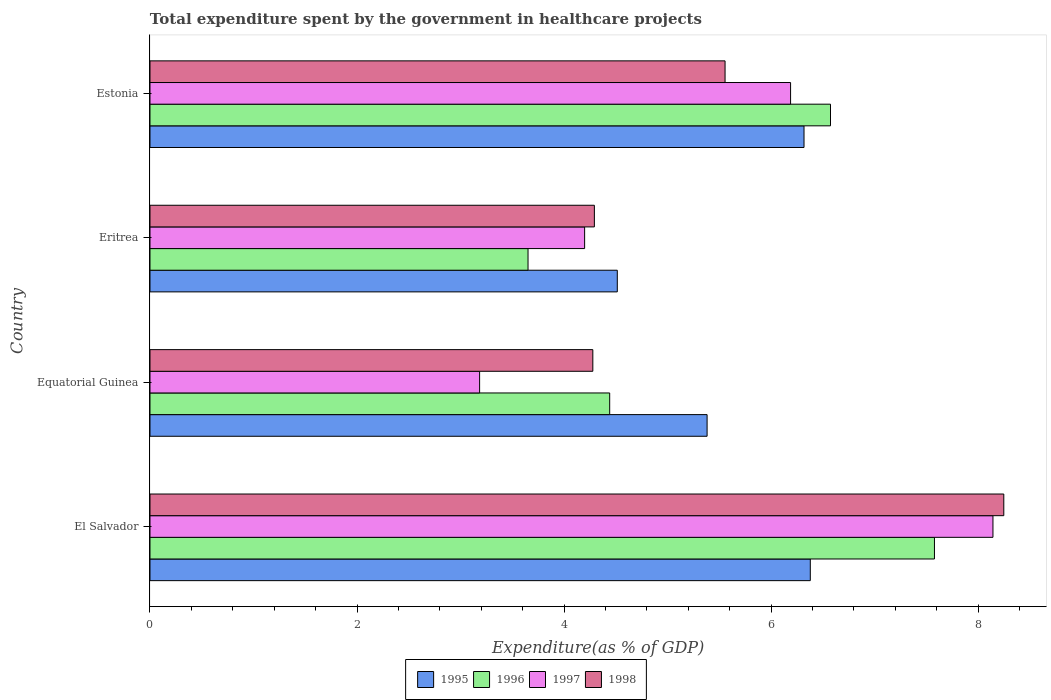How many groups of bars are there?
Keep it short and to the point. 4. Are the number of bars per tick equal to the number of legend labels?
Keep it short and to the point. Yes. What is the label of the 1st group of bars from the top?
Give a very brief answer. Estonia. What is the total expenditure spent by the government in healthcare projects in 1996 in Estonia?
Offer a terse response. 6.57. Across all countries, what is the maximum total expenditure spent by the government in healthcare projects in 1996?
Keep it short and to the point. 7.58. Across all countries, what is the minimum total expenditure spent by the government in healthcare projects in 1995?
Make the answer very short. 4.51. In which country was the total expenditure spent by the government in healthcare projects in 1996 maximum?
Keep it short and to the point. El Salvador. In which country was the total expenditure spent by the government in healthcare projects in 1998 minimum?
Give a very brief answer. Equatorial Guinea. What is the total total expenditure spent by the government in healthcare projects in 1997 in the graph?
Offer a terse response. 21.71. What is the difference between the total expenditure spent by the government in healthcare projects in 1996 in Eritrea and that in Estonia?
Provide a short and direct response. -2.92. What is the difference between the total expenditure spent by the government in healthcare projects in 1998 in Eritrea and the total expenditure spent by the government in healthcare projects in 1995 in Equatorial Guinea?
Your response must be concise. -1.09. What is the average total expenditure spent by the government in healthcare projects in 1998 per country?
Keep it short and to the point. 5.59. What is the difference between the total expenditure spent by the government in healthcare projects in 1996 and total expenditure spent by the government in healthcare projects in 1998 in Eritrea?
Your answer should be compact. -0.64. What is the ratio of the total expenditure spent by the government in healthcare projects in 1997 in Eritrea to that in Estonia?
Give a very brief answer. 0.68. Is the total expenditure spent by the government in healthcare projects in 1996 in Equatorial Guinea less than that in Eritrea?
Your answer should be compact. No. What is the difference between the highest and the second highest total expenditure spent by the government in healthcare projects in 1998?
Keep it short and to the point. 2.69. What is the difference between the highest and the lowest total expenditure spent by the government in healthcare projects in 1998?
Offer a very short reply. 3.97. What does the 2nd bar from the bottom in Eritrea represents?
Your response must be concise. 1996. How many bars are there?
Provide a succinct answer. 16. How many countries are there in the graph?
Offer a very short reply. 4. Does the graph contain any zero values?
Give a very brief answer. No. Where does the legend appear in the graph?
Offer a terse response. Bottom center. How are the legend labels stacked?
Your answer should be compact. Horizontal. What is the title of the graph?
Offer a very short reply. Total expenditure spent by the government in healthcare projects. Does "1981" appear as one of the legend labels in the graph?
Provide a succinct answer. No. What is the label or title of the X-axis?
Provide a short and direct response. Expenditure(as % of GDP). What is the Expenditure(as % of GDP) in 1995 in El Salvador?
Make the answer very short. 6.38. What is the Expenditure(as % of GDP) in 1996 in El Salvador?
Offer a terse response. 7.58. What is the Expenditure(as % of GDP) in 1997 in El Salvador?
Ensure brevity in your answer.  8.14. What is the Expenditure(as % of GDP) of 1998 in El Salvador?
Give a very brief answer. 8.25. What is the Expenditure(as % of GDP) of 1995 in Equatorial Guinea?
Offer a very short reply. 5.38. What is the Expenditure(as % of GDP) in 1996 in Equatorial Guinea?
Keep it short and to the point. 4.44. What is the Expenditure(as % of GDP) in 1997 in Equatorial Guinea?
Make the answer very short. 3.18. What is the Expenditure(as % of GDP) in 1998 in Equatorial Guinea?
Your response must be concise. 4.28. What is the Expenditure(as % of GDP) in 1995 in Eritrea?
Make the answer very short. 4.51. What is the Expenditure(as % of GDP) in 1996 in Eritrea?
Make the answer very short. 3.65. What is the Expenditure(as % of GDP) in 1997 in Eritrea?
Keep it short and to the point. 4.2. What is the Expenditure(as % of GDP) of 1998 in Eritrea?
Your response must be concise. 4.29. What is the Expenditure(as % of GDP) of 1995 in Estonia?
Offer a very short reply. 6.32. What is the Expenditure(as % of GDP) in 1996 in Estonia?
Offer a terse response. 6.57. What is the Expenditure(as % of GDP) of 1997 in Estonia?
Provide a short and direct response. 6.19. What is the Expenditure(as % of GDP) in 1998 in Estonia?
Keep it short and to the point. 5.56. Across all countries, what is the maximum Expenditure(as % of GDP) in 1995?
Give a very brief answer. 6.38. Across all countries, what is the maximum Expenditure(as % of GDP) of 1996?
Keep it short and to the point. 7.58. Across all countries, what is the maximum Expenditure(as % of GDP) in 1997?
Provide a succinct answer. 8.14. Across all countries, what is the maximum Expenditure(as % of GDP) of 1998?
Your answer should be very brief. 8.25. Across all countries, what is the minimum Expenditure(as % of GDP) of 1995?
Your answer should be compact. 4.51. Across all countries, what is the minimum Expenditure(as % of GDP) of 1996?
Ensure brevity in your answer.  3.65. Across all countries, what is the minimum Expenditure(as % of GDP) of 1997?
Your answer should be compact. 3.18. Across all countries, what is the minimum Expenditure(as % of GDP) of 1998?
Give a very brief answer. 4.28. What is the total Expenditure(as % of GDP) in 1995 in the graph?
Make the answer very short. 22.59. What is the total Expenditure(as % of GDP) in 1996 in the graph?
Keep it short and to the point. 22.24. What is the total Expenditure(as % of GDP) of 1997 in the graph?
Keep it short and to the point. 21.71. What is the total Expenditure(as % of GDP) of 1998 in the graph?
Offer a terse response. 22.37. What is the difference between the Expenditure(as % of GDP) of 1996 in El Salvador and that in Equatorial Guinea?
Offer a very short reply. 3.14. What is the difference between the Expenditure(as % of GDP) in 1997 in El Salvador and that in Equatorial Guinea?
Your answer should be compact. 4.96. What is the difference between the Expenditure(as % of GDP) in 1998 in El Salvador and that in Equatorial Guinea?
Your answer should be very brief. 3.97. What is the difference between the Expenditure(as % of GDP) of 1995 in El Salvador and that in Eritrea?
Offer a terse response. 1.86. What is the difference between the Expenditure(as % of GDP) of 1996 in El Salvador and that in Eritrea?
Your answer should be very brief. 3.93. What is the difference between the Expenditure(as % of GDP) of 1997 in El Salvador and that in Eritrea?
Your answer should be compact. 3.94. What is the difference between the Expenditure(as % of GDP) of 1998 in El Salvador and that in Eritrea?
Make the answer very short. 3.96. What is the difference between the Expenditure(as % of GDP) of 1995 in El Salvador and that in Estonia?
Ensure brevity in your answer.  0.06. What is the difference between the Expenditure(as % of GDP) of 1996 in El Salvador and that in Estonia?
Your answer should be very brief. 1. What is the difference between the Expenditure(as % of GDP) of 1997 in El Salvador and that in Estonia?
Keep it short and to the point. 1.95. What is the difference between the Expenditure(as % of GDP) in 1998 in El Salvador and that in Estonia?
Your answer should be compact. 2.69. What is the difference between the Expenditure(as % of GDP) of 1995 in Equatorial Guinea and that in Eritrea?
Your answer should be compact. 0.87. What is the difference between the Expenditure(as % of GDP) of 1996 in Equatorial Guinea and that in Eritrea?
Your answer should be very brief. 0.79. What is the difference between the Expenditure(as % of GDP) in 1997 in Equatorial Guinea and that in Eritrea?
Provide a short and direct response. -1.01. What is the difference between the Expenditure(as % of GDP) of 1998 in Equatorial Guinea and that in Eritrea?
Keep it short and to the point. -0.01. What is the difference between the Expenditure(as % of GDP) of 1995 in Equatorial Guinea and that in Estonia?
Offer a terse response. -0.94. What is the difference between the Expenditure(as % of GDP) of 1996 in Equatorial Guinea and that in Estonia?
Provide a short and direct response. -2.13. What is the difference between the Expenditure(as % of GDP) in 1997 in Equatorial Guinea and that in Estonia?
Give a very brief answer. -3. What is the difference between the Expenditure(as % of GDP) in 1998 in Equatorial Guinea and that in Estonia?
Your answer should be compact. -1.28. What is the difference between the Expenditure(as % of GDP) in 1995 in Eritrea and that in Estonia?
Make the answer very short. -1.8. What is the difference between the Expenditure(as % of GDP) of 1996 in Eritrea and that in Estonia?
Give a very brief answer. -2.92. What is the difference between the Expenditure(as % of GDP) in 1997 in Eritrea and that in Estonia?
Offer a very short reply. -1.99. What is the difference between the Expenditure(as % of GDP) of 1998 in Eritrea and that in Estonia?
Keep it short and to the point. -1.26. What is the difference between the Expenditure(as % of GDP) of 1995 in El Salvador and the Expenditure(as % of GDP) of 1996 in Equatorial Guinea?
Provide a short and direct response. 1.94. What is the difference between the Expenditure(as % of GDP) in 1995 in El Salvador and the Expenditure(as % of GDP) in 1997 in Equatorial Guinea?
Offer a terse response. 3.19. What is the difference between the Expenditure(as % of GDP) of 1995 in El Salvador and the Expenditure(as % of GDP) of 1998 in Equatorial Guinea?
Provide a short and direct response. 2.1. What is the difference between the Expenditure(as % of GDP) of 1996 in El Salvador and the Expenditure(as % of GDP) of 1997 in Equatorial Guinea?
Provide a succinct answer. 4.39. What is the difference between the Expenditure(as % of GDP) in 1996 in El Salvador and the Expenditure(as % of GDP) in 1998 in Equatorial Guinea?
Make the answer very short. 3.3. What is the difference between the Expenditure(as % of GDP) of 1997 in El Salvador and the Expenditure(as % of GDP) of 1998 in Equatorial Guinea?
Give a very brief answer. 3.87. What is the difference between the Expenditure(as % of GDP) in 1995 in El Salvador and the Expenditure(as % of GDP) in 1996 in Eritrea?
Provide a short and direct response. 2.73. What is the difference between the Expenditure(as % of GDP) in 1995 in El Salvador and the Expenditure(as % of GDP) in 1997 in Eritrea?
Ensure brevity in your answer.  2.18. What is the difference between the Expenditure(as % of GDP) in 1995 in El Salvador and the Expenditure(as % of GDP) in 1998 in Eritrea?
Offer a very short reply. 2.09. What is the difference between the Expenditure(as % of GDP) in 1996 in El Salvador and the Expenditure(as % of GDP) in 1997 in Eritrea?
Give a very brief answer. 3.38. What is the difference between the Expenditure(as % of GDP) of 1996 in El Salvador and the Expenditure(as % of GDP) of 1998 in Eritrea?
Keep it short and to the point. 3.29. What is the difference between the Expenditure(as % of GDP) of 1997 in El Salvador and the Expenditure(as % of GDP) of 1998 in Eritrea?
Ensure brevity in your answer.  3.85. What is the difference between the Expenditure(as % of GDP) in 1995 in El Salvador and the Expenditure(as % of GDP) in 1996 in Estonia?
Provide a short and direct response. -0.2. What is the difference between the Expenditure(as % of GDP) in 1995 in El Salvador and the Expenditure(as % of GDP) in 1997 in Estonia?
Your answer should be compact. 0.19. What is the difference between the Expenditure(as % of GDP) in 1995 in El Salvador and the Expenditure(as % of GDP) in 1998 in Estonia?
Provide a short and direct response. 0.82. What is the difference between the Expenditure(as % of GDP) of 1996 in El Salvador and the Expenditure(as % of GDP) of 1997 in Estonia?
Ensure brevity in your answer.  1.39. What is the difference between the Expenditure(as % of GDP) in 1996 in El Salvador and the Expenditure(as % of GDP) in 1998 in Estonia?
Your response must be concise. 2.02. What is the difference between the Expenditure(as % of GDP) of 1997 in El Salvador and the Expenditure(as % of GDP) of 1998 in Estonia?
Provide a short and direct response. 2.59. What is the difference between the Expenditure(as % of GDP) in 1995 in Equatorial Guinea and the Expenditure(as % of GDP) in 1996 in Eritrea?
Ensure brevity in your answer.  1.73. What is the difference between the Expenditure(as % of GDP) in 1995 in Equatorial Guinea and the Expenditure(as % of GDP) in 1997 in Eritrea?
Your response must be concise. 1.18. What is the difference between the Expenditure(as % of GDP) in 1995 in Equatorial Guinea and the Expenditure(as % of GDP) in 1998 in Eritrea?
Keep it short and to the point. 1.09. What is the difference between the Expenditure(as % of GDP) in 1996 in Equatorial Guinea and the Expenditure(as % of GDP) in 1997 in Eritrea?
Your answer should be compact. 0.24. What is the difference between the Expenditure(as % of GDP) of 1996 in Equatorial Guinea and the Expenditure(as % of GDP) of 1998 in Eritrea?
Give a very brief answer. 0.15. What is the difference between the Expenditure(as % of GDP) of 1997 in Equatorial Guinea and the Expenditure(as % of GDP) of 1998 in Eritrea?
Offer a terse response. -1.11. What is the difference between the Expenditure(as % of GDP) in 1995 in Equatorial Guinea and the Expenditure(as % of GDP) in 1996 in Estonia?
Your answer should be very brief. -1.19. What is the difference between the Expenditure(as % of GDP) in 1995 in Equatorial Guinea and the Expenditure(as % of GDP) in 1997 in Estonia?
Provide a short and direct response. -0.81. What is the difference between the Expenditure(as % of GDP) in 1995 in Equatorial Guinea and the Expenditure(as % of GDP) in 1998 in Estonia?
Make the answer very short. -0.17. What is the difference between the Expenditure(as % of GDP) of 1996 in Equatorial Guinea and the Expenditure(as % of GDP) of 1997 in Estonia?
Offer a very short reply. -1.75. What is the difference between the Expenditure(as % of GDP) of 1996 in Equatorial Guinea and the Expenditure(as % of GDP) of 1998 in Estonia?
Give a very brief answer. -1.11. What is the difference between the Expenditure(as % of GDP) in 1997 in Equatorial Guinea and the Expenditure(as % of GDP) in 1998 in Estonia?
Offer a terse response. -2.37. What is the difference between the Expenditure(as % of GDP) in 1995 in Eritrea and the Expenditure(as % of GDP) in 1996 in Estonia?
Your answer should be very brief. -2.06. What is the difference between the Expenditure(as % of GDP) in 1995 in Eritrea and the Expenditure(as % of GDP) in 1997 in Estonia?
Keep it short and to the point. -1.67. What is the difference between the Expenditure(as % of GDP) of 1995 in Eritrea and the Expenditure(as % of GDP) of 1998 in Estonia?
Ensure brevity in your answer.  -1.04. What is the difference between the Expenditure(as % of GDP) of 1996 in Eritrea and the Expenditure(as % of GDP) of 1997 in Estonia?
Give a very brief answer. -2.54. What is the difference between the Expenditure(as % of GDP) in 1996 in Eritrea and the Expenditure(as % of GDP) in 1998 in Estonia?
Make the answer very short. -1.9. What is the difference between the Expenditure(as % of GDP) of 1997 in Eritrea and the Expenditure(as % of GDP) of 1998 in Estonia?
Keep it short and to the point. -1.36. What is the average Expenditure(as % of GDP) of 1995 per country?
Provide a succinct answer. 5.65. What is the average Expenditure(as % of GDP) in 1996 per country?
Your response must be concise. 5.56. What is the average Expenditure(as % of GDP) of 1997 per country?
Offer a terse response. 5.43. What is the average Expenditure(as % of GDP) of 1998 per country?
Your answer should be compact. 5.59. What is the difference between the Expenditure(as % of GDP) in 1995 and Expenditure(as % of GDP) in 1996 in El Salvador?
Make the answer very short. -1.2. What is the difference between the Expenditure(as % of GDP) in 1995 and Expenditure(as % of GDP) in 1997 in El Salvador?
Make the answer very short. -1.76. What is the difference between the Expenditure(as % of GDP) of 1995 and Expenditure(as % of GDP) of 1998 in El Salvador?
Ensure brevity in your answer.  -1.87. What is the difference between the Expenditure(as % of GDP) of 1996 and Expenditure(as % of GDP) of 1997 in El Salvador?
Provide a short and direct response. -0.56. What is the difference between the Expenditure(as % of GDP) of 1996 and Expenditure(as % of GDP) of 1998 in El Salvador?
Give a very brief answer. -0.67. What is the difference between the Expenditure(as % of GDP) in 1997 and Expenditure(as % of GDP) in 1998 in El Salvador?
Keep it short and to the point. -0.1. What is the difference between the Expenditure(as % of GDP) in 1995 and Expenditure(as % of GDP) in 1996 in Equatorial Guinea?
Your response must be concise. 0.94. What is the difference between the Expenditure(as % of GDP) in 1995 and Expenditure(as % of GDP) in 1997 in Equatorial Guinea?
Provide a short and direct response. 2.2. What is the difference between the Expenditure(as % of GDP) of 1995 and Expenditure(as % of GDP) of 1998 in Equatorial Guinea?
Keep it short and to the point. 1.1. What is the difference between the Expenditure(as % of GDP) of 1996 and Expenditure(as % of GDP) of 1997 in Equatorial Guinea?
Provide a short and direct response. 1.26. What is the difference between the Expenditure(as % of GDP) of 1996 and Expenditure(as % of GDP) of 1998 in Equatorial Guinea?
Your answer should be compact. 0.16. What is the difference between the Expenditure(as % of GDP) of 1997 and Expenditure(as % of GDP) of 1998 in Equatorial Guinea?
Your answer should be very brief. -1.09. What is the difference between the Expenditure(as % of GDP) of 1995 and Expenditure(as % of GDP) of 1996 in Eritrea?
Make the answer very short. 0.86. What is the difference between the Expenditure(as % of GDP) of 1995 and Expenditure(as % of GDP) of 1997 in Eritrea?
Give a very brief answer. 0.32. What is the difference between the Expenditure(as % of GDP) of 1995 and Expenditure(as % of GDP) of 1998 in Eritrea?
Offer a terse response. 0.22. What is the difference between the Expenditure(as % of GDP) in 1996 and Expenditure(as % of GDP) in 1997 in Eritrea?
Your answer should be very brief. -0.55. What is the difference between the Expenditure(as % of GDP) in 1996 and Expenditure(as % of GDP) in 1998 in Eritrea?
Your answer should be very brief. -0.64. What is the difference between the Expenditure(as % of GDP) in 1997 and Expenditure(as % of GDP) in 1998 in Eritrea?
Your response must be concise. -0.09. What is the difference between the Expenditure(as % of GDP) of 1995 and Expenditure(as % of GDP) of 1996 in Estonia?
Your response must be concise. -0.26. What is the difference between the Expenditure(as % of GDP) of 1995 and Expenditure(as % of GDP) of 1997 in Estonia?
Offer a very short reply. 0.13. What is the difference between the Expenditure(as % of GDP) in 1995 and Expenditure(as % of GDP) in 1998 in Estonia?
Offer a terse response. 0.76. What is the difference between the Expenditure(as % of GDP) of 1996 and Expenditure(as % of GDP) of 1997 in Estonia?
Provide a succinct answer. 0.39. What is the difference between the Expenditure(as % of GDP) of 1996 and Expenditure(as % of GDP) of 1998 in Estonia?
Offer a terse response. 1.02. What is the difference between the Expenditure(as % of GDP) in 1997 and Expenditure(as % of GDP) in 1998 in Estonia?
Provide a short and direct response. 0.63. What is the ratio of the Expenditure(as % of GDP) of 1995 in El Salvador to that in Equatorial Guinea?
Keep it short and to the point. 1.19. What is the ratio of the Expenditure(as % of GDP) in 1996 in El Salvador to that in Equatorial Guinea?
Your answer should be compact. 1.71. What is the ratio of the Expenditure(as % of GDP) of 1997 in El Salvador to that in Equatorial Guinea?
Provide a short and direct response. 2.56. What is the ratio of the Expenditure(as % of GDP) of 1998 in El Salvador to that in Equatorial Guinea?
Ensure brevity in your answer.  1.93. What is the ratio of the Expenditure(as % of GDP) of 1995 in El Salvador to that in Eritrea?
Your answer should be very brief. 1.41. What is the ratio of the Expenditure(as % of GDP) in 1996 in El Salvador to that in Eritrea?
Your answer should be compact. 2.08. What is the ratio of the Expenditure(as % of GDP) in 1997 in El Salvador to that in Eritrea?
Your answer should be very brief. 1.94. What is the ratio of the Expenditure(as % of GDP) in 1998 in El Salvador to that in Eritrea?
Provide a short and direct response. 1.92. What is the ratio of the Expenditure(as % of GDP) in 1995 in El Salvador to that in Estonia?
Your response must be concise. 1.01. What is the ratio of the Expenditure(as % of GDP) of 1996 in El Salvador to that in Estonia?
Offer a very short reply. 1.15. What is the ratio of the Expenditure(as % of GDP) in 1997 in El Salvador to that in Estonia?
Your answer should be compact. 1.32. What is the ratio of the Expenditure(as % of GDP) in 1998 in El Salvador to that in Estonia?
Provide a succinct answer. 1.48. What is the ratio of the Expenditure(as % of GDP) of 1995 in Equatorial Guinea to that in Eritrea?
Provide a short and direct response. 1.19. What is the ratio of the Expenditure(as % of GDP) of 1996 in Equatorial Guinea to that in Eritrea?
Provide a succinct answer. 1.22. What is the ratio of the Expenditure(as % of GDP) in 1997 in Equatorial Guinea to that in Eritrea?
Provide a short and direct response. 0.76. What is the ratio of the Expenditure(as % of GDP) of 1995 in Equatorial Guinea to that in Estonia?
Your answer should be very brief. 0.85. What is the ratio of the Expenditure(as % of GDP) in 1996 in Equatorial Guinea to that in Estonia?
Keep it short and to the point. 0.68. What is the ratio of the Expenditure(as % of GDP) of 1997 in Equatorial Guinea to that in Estonia?
Your answer should be very brief. 0.51. What is the ratio of the Expenditure(as % of GDP) in 1998 in Equatorial Guinea to that in Estonia?
Give a very brief answer. 0.77. What is the ratio of the Expenditure(as % of GDP) of 1995 in Eritrea to that in Estonia?
Your answer should be compact. 0.71. What is the ratio of the Expenditure(as % of GDP) in 1996 in Eritrea to that in Estonia?
Your response must be concise. 0.56. What is the ratio of the Expenditure(as % of GDP) in 1997 in Eritrea to that in Estonia?
Your response must be concise. 0.68. What is the ratio of the Expenditure(as % of GDP) in 1998 in Eritrea to that in Estonia?
Offer a very short reply. 0.77. What is the difference between the highest and the second highest Expenditure(as % of GDP) of 1995?
Ensure brevity in your answer.  0.06. What is the difference between the highest and the second highest Expenditure(as % of GDP) in 1996?
Offer a terse response. 1. What is the difference between the highest and the second highest Expenditure(as % of GDP) in 1997?
Provide a short and direct response. 1.95. What is the difference between the highest and the second highest Expenditure(as % of GDP) in 1998?
Offer a very short reply. 2.69. What is the difference between the highest and the lowest Expenditure(as % of GDP) of 1995?
Provide a succinct answer. 1.86. What is the difference between the highest and the lowest Expenditure(as % of GDP) of 1996?
Your answer should be compact. 3.93. What is the difference between the highest and the lowest Expenditure(as % of GDP) of 1997?
Provide a short and direct response. 4.96. What is the difference between the highest and the lowest Expenditure(as % of GDP) of 1998?
Provide a short and direct response. 3.97. 